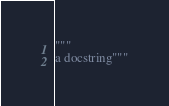Convert code to text. <code><loc_0><loc_0><loc_500><loc_500><_Python_>"""
a docstring"""
</code> 